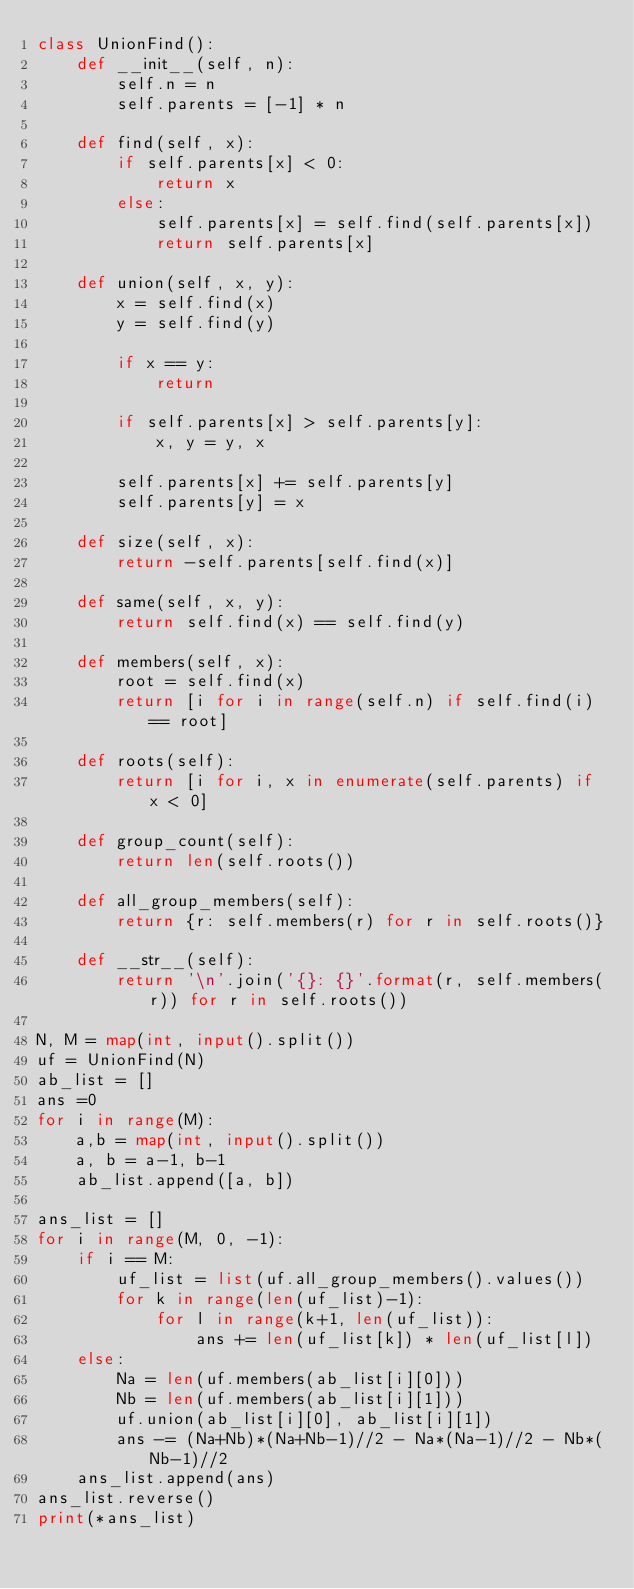<code> <loc_0><loc_0><loc_500><loc_500><_Python_>class UnionFind():
    def __init__(self, n):
        self.n = n
        self.parents = [-1] * n

    def find(self, x):
        if self.parents[x] < 0:
            return x
        else:
            self.parents[x] = self.find(self.parents[x])
            return self.parents[x]

    def union(self, x, y):
        x = self.find(x)
        y = self.find(y)

        if x == y:
            return

        if self.parents[x] > self.parents[y]:
            x, y = y, x

        self.parents[x] += self.parents[y]
        self.parents[y] = x

    def size(self, x):
        return -self.parents[self.find(x)]

    def same(self, x, y):
        return self.find(x) == self.find(y)

    def members(self, x):
        root = self.find(x)
        return [i for i in range(self.n) if self.find(i) == root]

    def roots(self):
        return [i for i, x in enumerate(self.parents) if x < 0]

    def group_count(self):
        return len(self.roots())

    def all_group_members(self):
        return {r: self.members(r) for r in self.roots()}

    def __str__(self):
        return '\n'.join('{}: {}'.format(r, self.members(r)) for r in self.roots())

N, M = map(int, input().split())
uf = UnionFind(N)
ab_list = []
ans =0
for i in range(M):
    a,b = map(int, input().split())
    a, b = a-1, b-1
    ab_list.append([a, b])

ans_list = []
for i in range(M, 0, -1):
    if i == M:
        uf_list = list(uf.all_group_members().values())
        for k in range(len(uf_list)-1):
            for l in range(k+1, len(uf_list)):
                ans += len(uf_list[k]) * len(uf_list[l])
    else:
        Na = len(uf.members(ab_list[i][0]))
        Nb = len(uf.members(ab_list[i][1]))
        uf.union(ab_list[i][0], ab_list[i][1])
        ans -= (Na+Nb)*(Na+Nb-1)//2 - Na*(Na-1)//2 - Nb*(Nb-1)//2
    ans_list.append(ans)
ans_list.reverse()
print(*ans_list)
</code> 